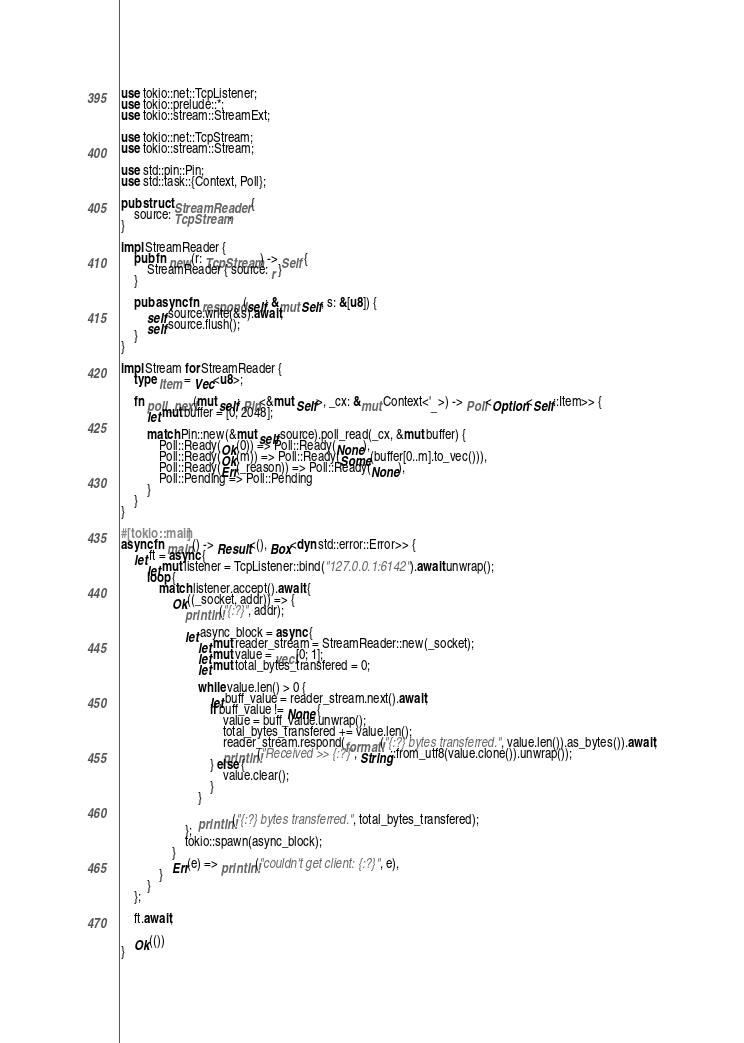Convert code to text. <code><loc_0><loc_0><loc_500><loc_500><_Rust_>use tokio::net::TcpListener;
use tokio::prelude::*;
use tokio::stream::StreamExt;

use tokio::net::TcpStream;
use tokio::stream::Stream;

use std::pin::Pin;
use std::task::{Context, Poll};

pub struct StreamReader {
    source: TcpStream,
}

impl StreamReader {
    pub fn new(r: TcpStream) -> Self {
        StreamReader { source: r }
    }

    pub async fn respond(self: &mut Self, s: &[u8]) {
        self.source.write(&s).await;
        self.source.flush();
    }
}

impl Stream for StreamReader {
    type Item = Vec<u8>;

    fn poll_next(mut self: Pin<&mut Self>, _cx: &mut Context<'_>) -> Poll<Option<Self::Item>> {
        let mut buffer = [0; 2048];

        match Pin::new(&mut self.source).poll_read(_cx, &mut buffer) {
            Poll::Ready(Ok(0)) => Poll::Ready(None),
            Poll::Ready(Ok(m)) => Poll::Ready(Some(buffer[0..m].to_vec())),
            Poll::Ready(Err(_reason)) => Poll::Ready(None),
            Poll::Pending => Poll::Pending
        }
    }
}

#[tokio::main]
async fn main() -> Result<(), Box<dyn std::error::Error>> {
    let ft = async {
        let mut listener = TcpListener::bind("127.0.0.1:6142").await.unwrap();
        loop {
            match listener.accept().await {
                Ok((_socket, addr)) => {
                    println!("{:?}", addr);

                    let async_block = async {
                        let mut reader_stream = StreamReader::new(_socket);
                        let mut value = vec![0; 1];
                        let mut total_bytes_transfered = 0;

                        while value.len() > 0 {
                            let buff_value = reader_stream.next().await;
                            if buff_value != None {
                                value = buff_value.unwrap();
                                total_bytes_transfered += value.len();
                                reader_stream.respond(format!("{:?} bytes transferred.", value.len()).as_bytes()).await;
                                println!("Received >> {:?}", String::from_utf8(value.clone()).unwrap());
                            } else {
                                value.clear();
                            }
                        }

                        println!("{:?} bytes transferred.", total_bytes_transfered);
                    };
                    tokio::spawn(async_block);
                }
                Err(e) => println!("couldn't get client: {:?}", e),
            }
        }
    };

    ft.await;

    Ok(())
}
</code> 